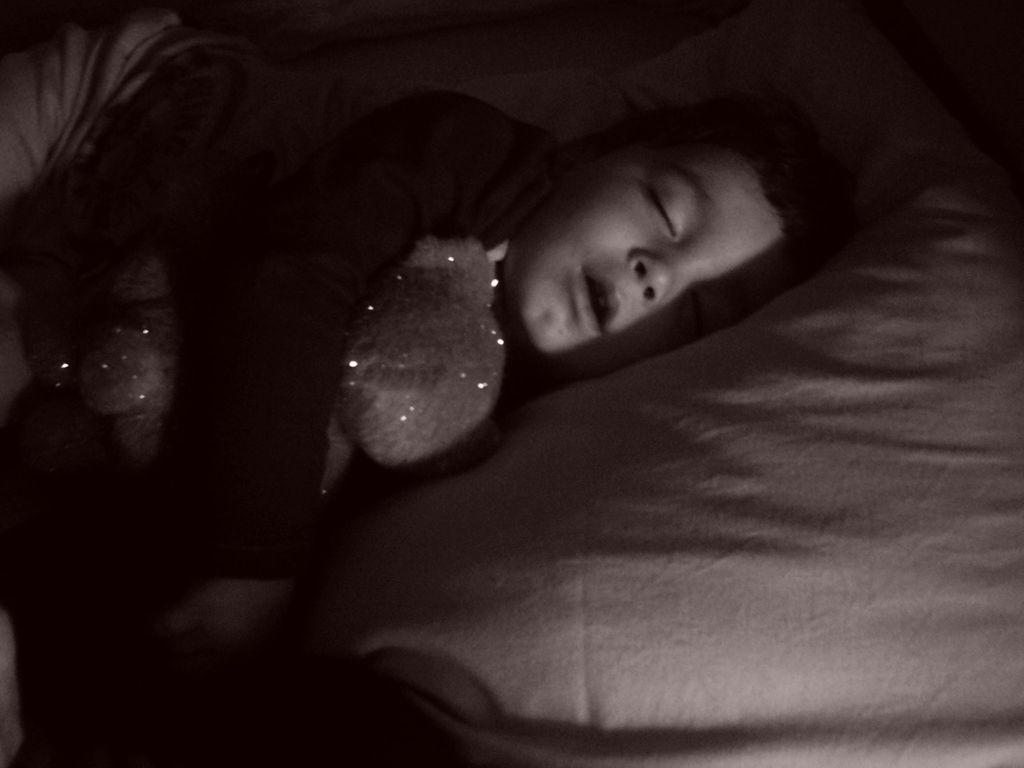Could you give a brief overview of what you see in this image? This is a black and white image. In this image we can see a boy sleeping on a bed holding a doll. 